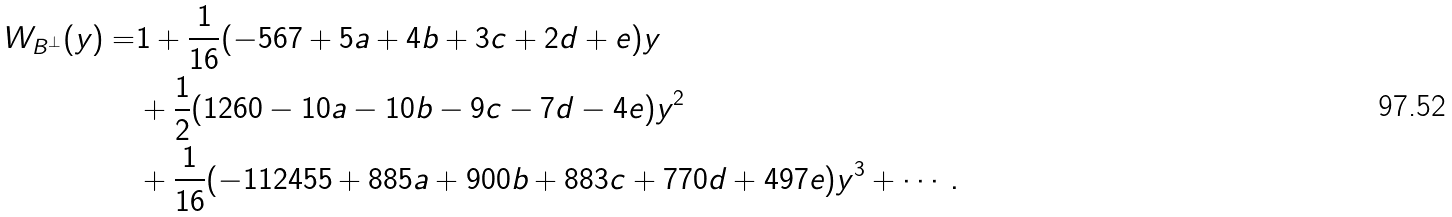<formula> <loc_0><loc_0><loc_500><loc_500>W _ { B ^ { \perp } } ( y ) = & 1 + \frac { 1 } { 1 6 } ( - 5 6 7 + 5 a + 4 b + 3 c + 2 d + e ) y \\ & + \frac { 1 } { 2 } ( 1 2 6 0 - 1 0 a - 1 0 b - 9 c - 7 d - 4 e ) y ^ { 2 } \\ & + \frac { 1 } { 1 6 } ( - 1 1 2 4 5 5 + 8 8 5 a + 9 0 0 b + 8 8 3 c + 7 7 0 d + 4 9 7 e ) y ^ { 3 } + \cdots .</formula> 